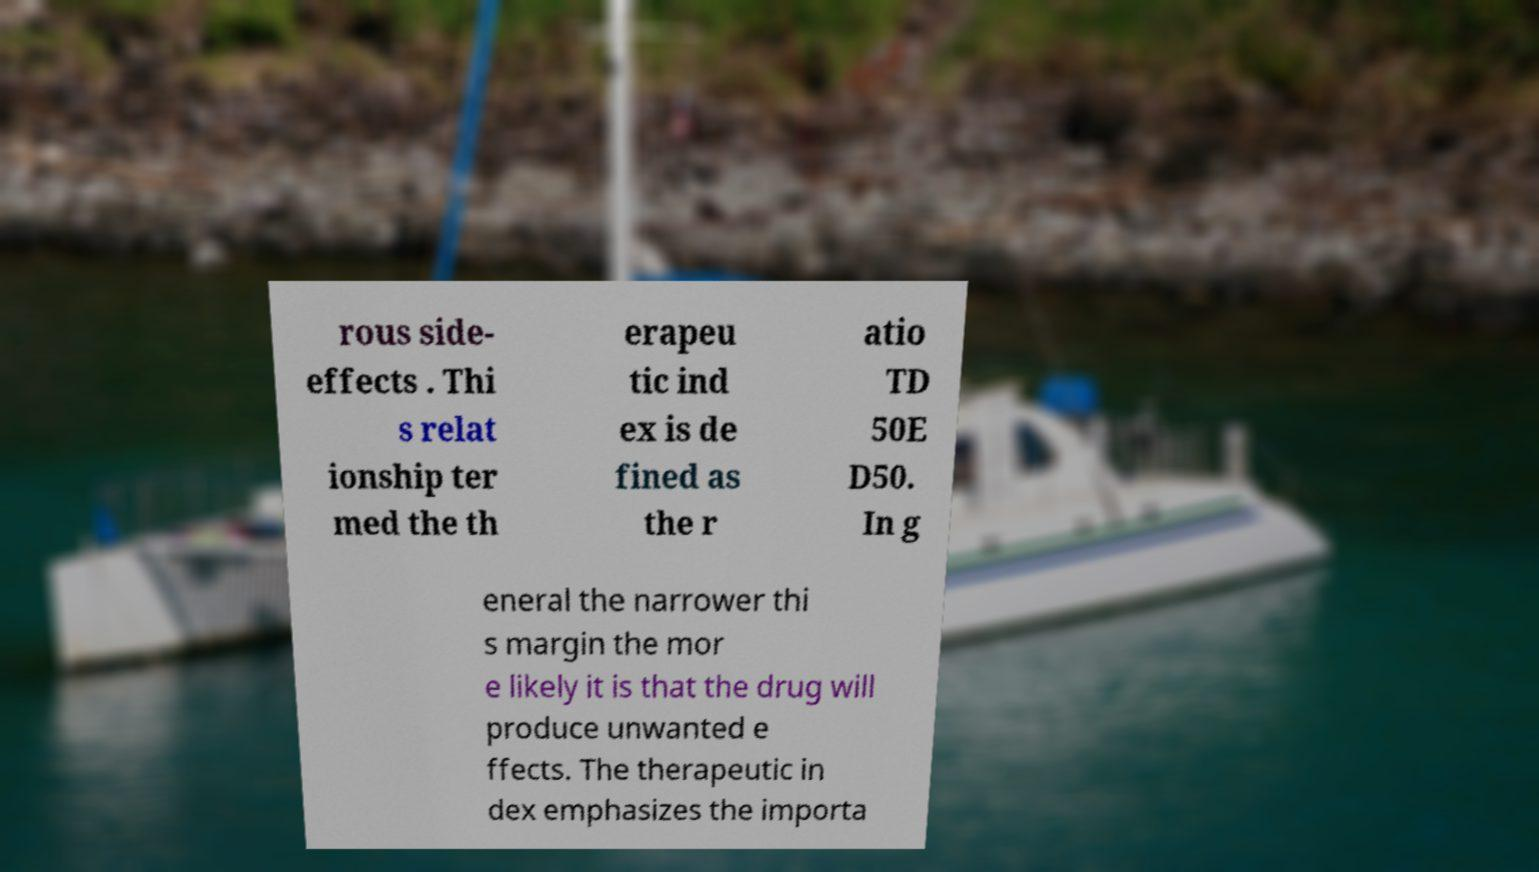Could you extract and type out the text from this image? rous side- effects . Thi s relat ionship ter med the th erapeu tic ind ex is de fined as the r atio TD 50E D50. In g eneral the narrower thi s margin the mor e likely it is that the drug will produce unwanted e ffects. The therapeutic in dex emphasizes the importa 